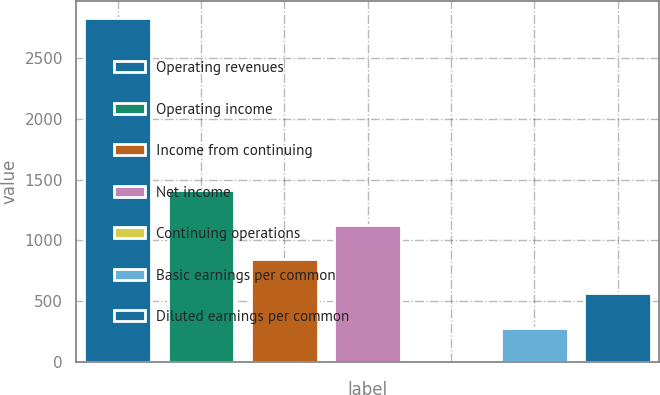Convert chart. <chart><loc_0><loc_0><loc_500><loc_500><bar_chart><fcel>Operating revenues<fcel>Operating income<fcel>Income from continuing<fcel>Net income<fcel>Continuing operations<fcel>Basic earnings per common<fcel>Diluted earnings per common<nl><fcel>2824<fcel>1412.38<fcel>847.74<fcel>1130.06<fcel>0.78<fcel>283.1<fcel>565.42<nl></chart> 